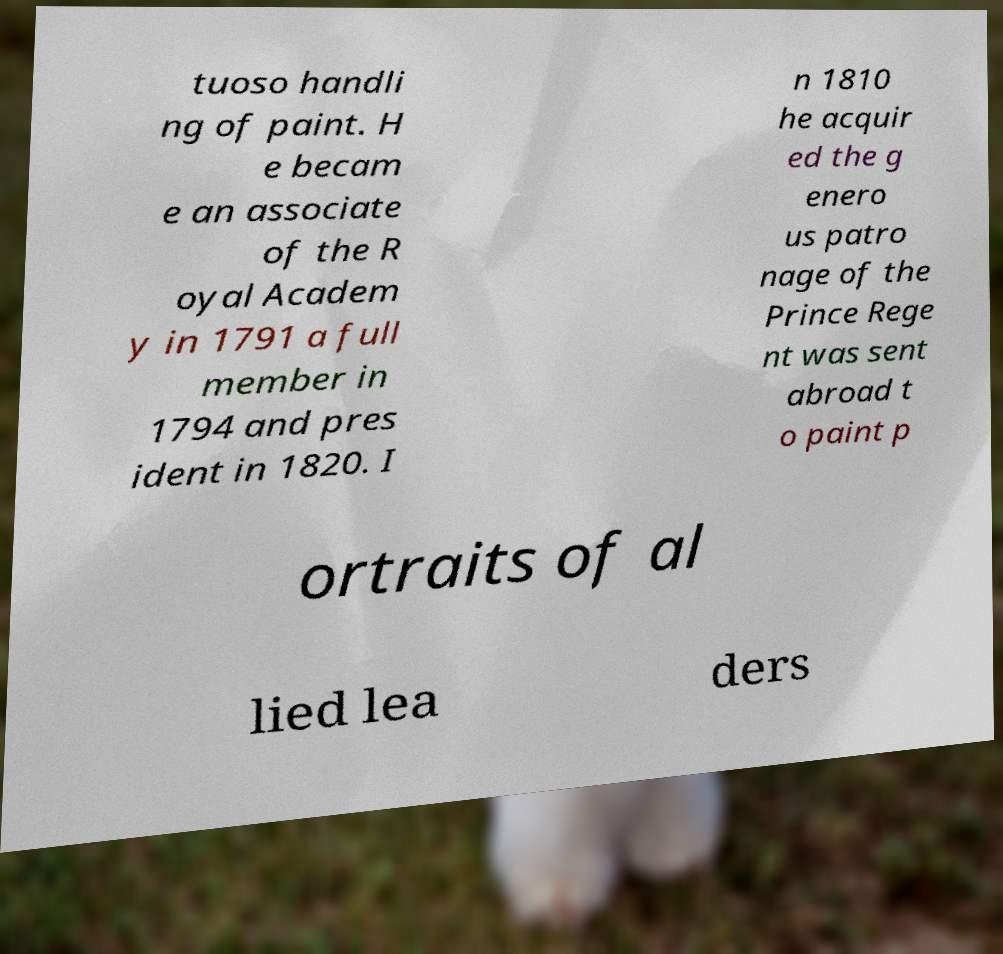There's text embedded in this image that I need extracted. Can you transcribe it verbatim? tuoso handli ng of paint. H e becam e an associate of the R oyal Academ y in 1791 a full member in 1794 and pres ident in 1820. I n 1810 he acquir ed the g enero us patro nage of the Prince Rege nt was sent abroad t o paint p ortraits of al lied lea ders 